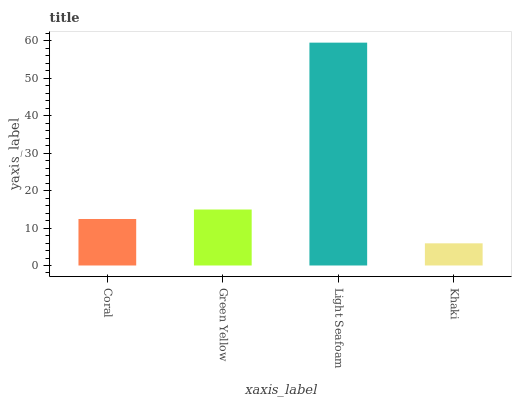Is Green Yellow the minimum?
Answer yes or no. No. Is Green Yellow the maximum?
Answer yes or no. No. Is Green Yellow greater than Coral?
Answer yes or no. Yes. Is Coral less than Green Yellow?
Answer yes or no. Yes. Is Coral greater than Green Yellow?
Answer yes or no. No. Is Green Yellow less than Coral?
Answer yes or no. No. Is Green Yellow the high median?
Answer yes or no. Yes. Is Coral the low median?
Answer yes or no. Yes. Is Light Seafoam the high median?
Answer yes or no. No. Is Khaki the low median?
Answer yes or no. No. 